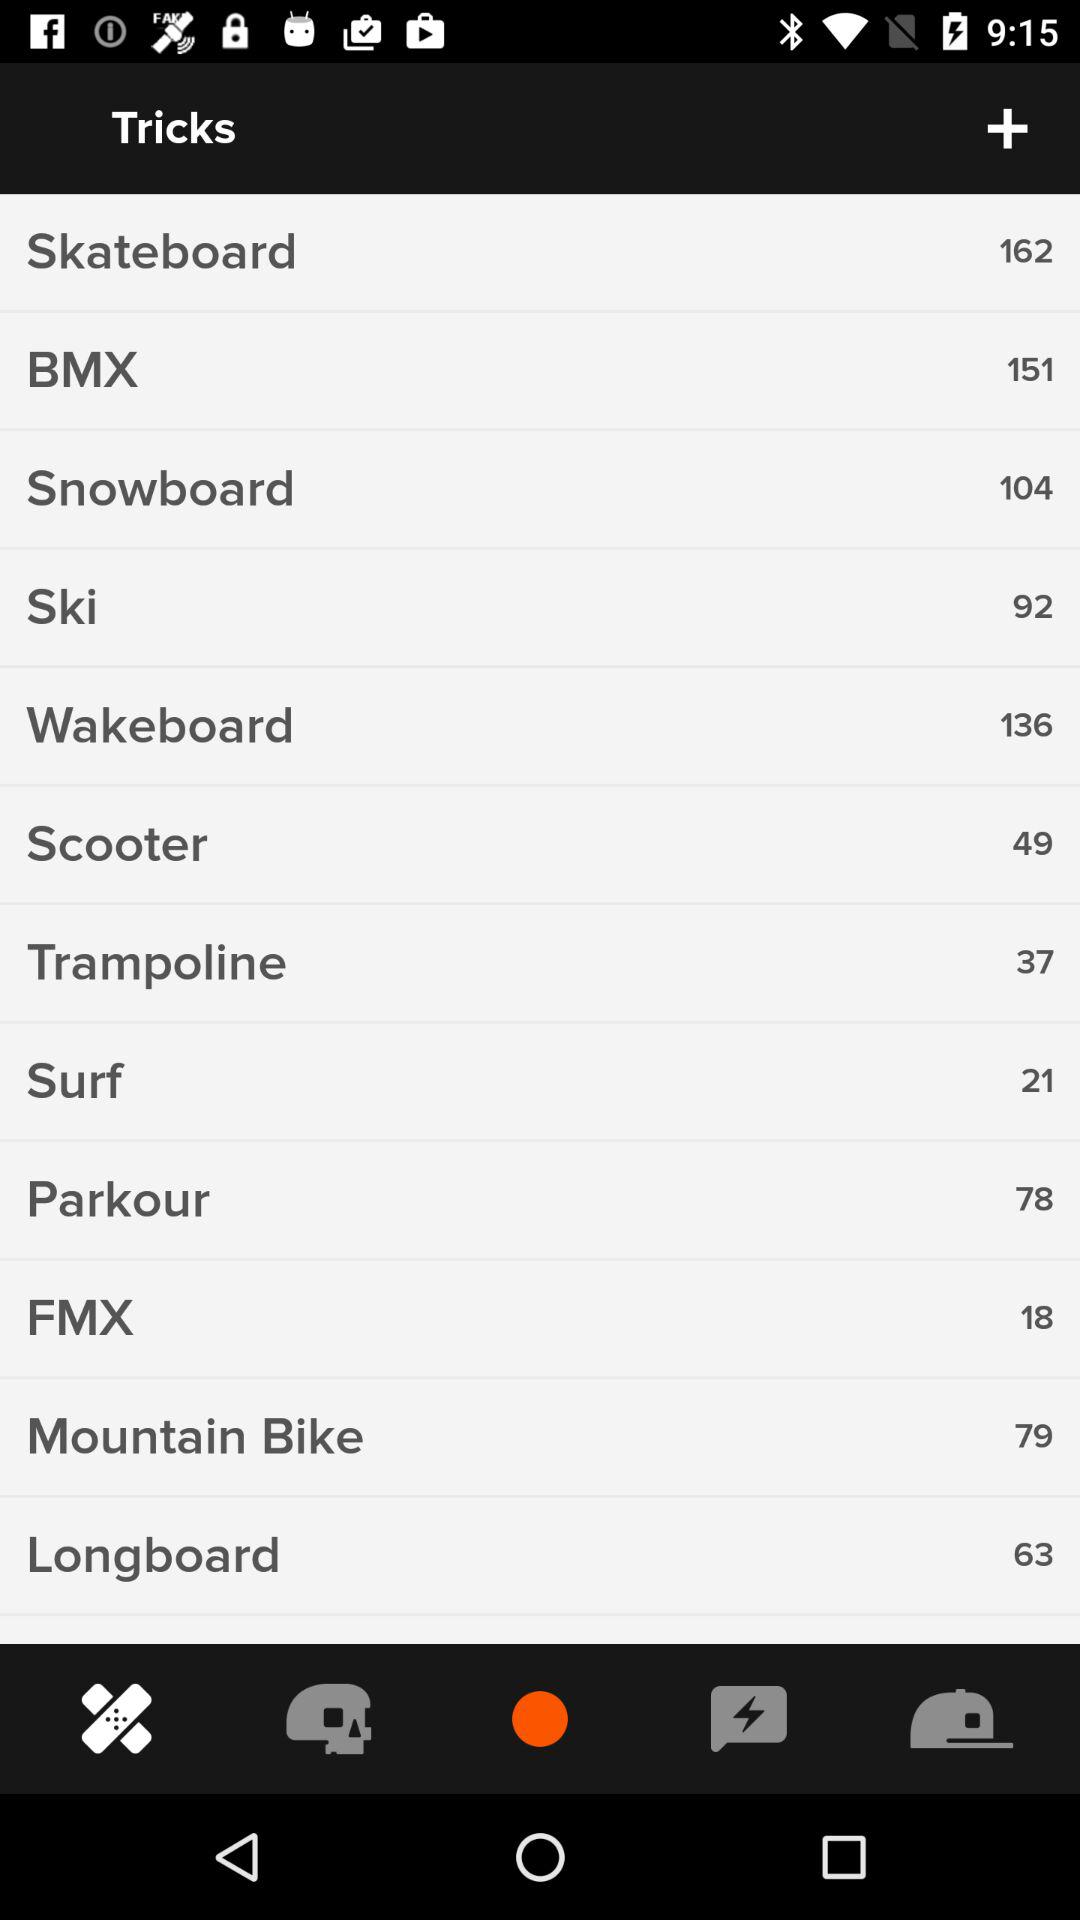What is the number of "Skateboard"? The number is 162. 